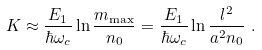Convert formula to latex. <formula><loc_0><loc_0><loc_500><loc_500>K \approx \frac { E _ { 1 } } { \hbar { \omega } _ { c } } \ln \frac { m _ { \max } } { n _ { 0 } } = \frac { E _ { 1 } } { \hbar { \omega } _ { c } } \ln \frac { l ^ { 2 } } { a ^ { 2 } n _ { 0 } } \ .</formula> 